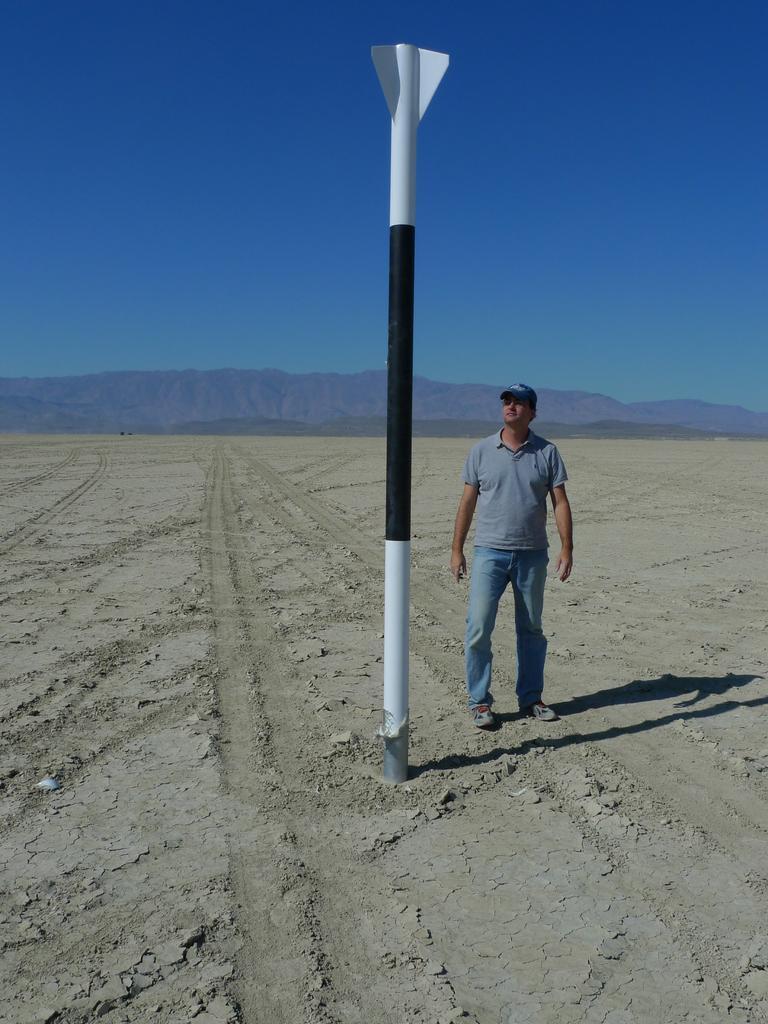Please provide a concise description of this image. In the foreground of this image, there is a man standing on the land and there is also a pole in front of him. In the background, there are mountains and the sky. 